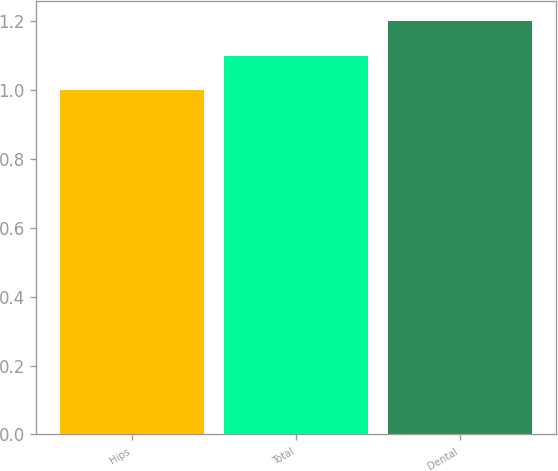Convert chart to OTSL. <chart><loc_0><loc_0><loc_500><loc_500><bar_chart><fcel>Hips<fcel>Total<fcel>Dental<nl><fcel>1<fcel>1.1<fcel>1.2<nl></chart> 